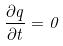<formula> <loc_0><loc_0><loc_500><loc_500>\frac { \partial q } { \partial t } = 0</formula> 